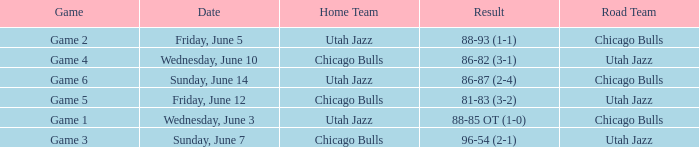What game has a score of 86-87 (2-4)? Game 6. 